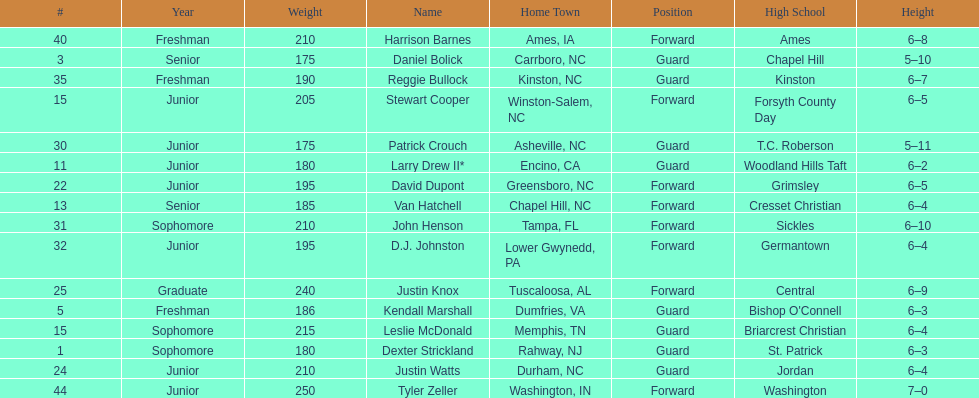How many players play a position other than guard? 8. 